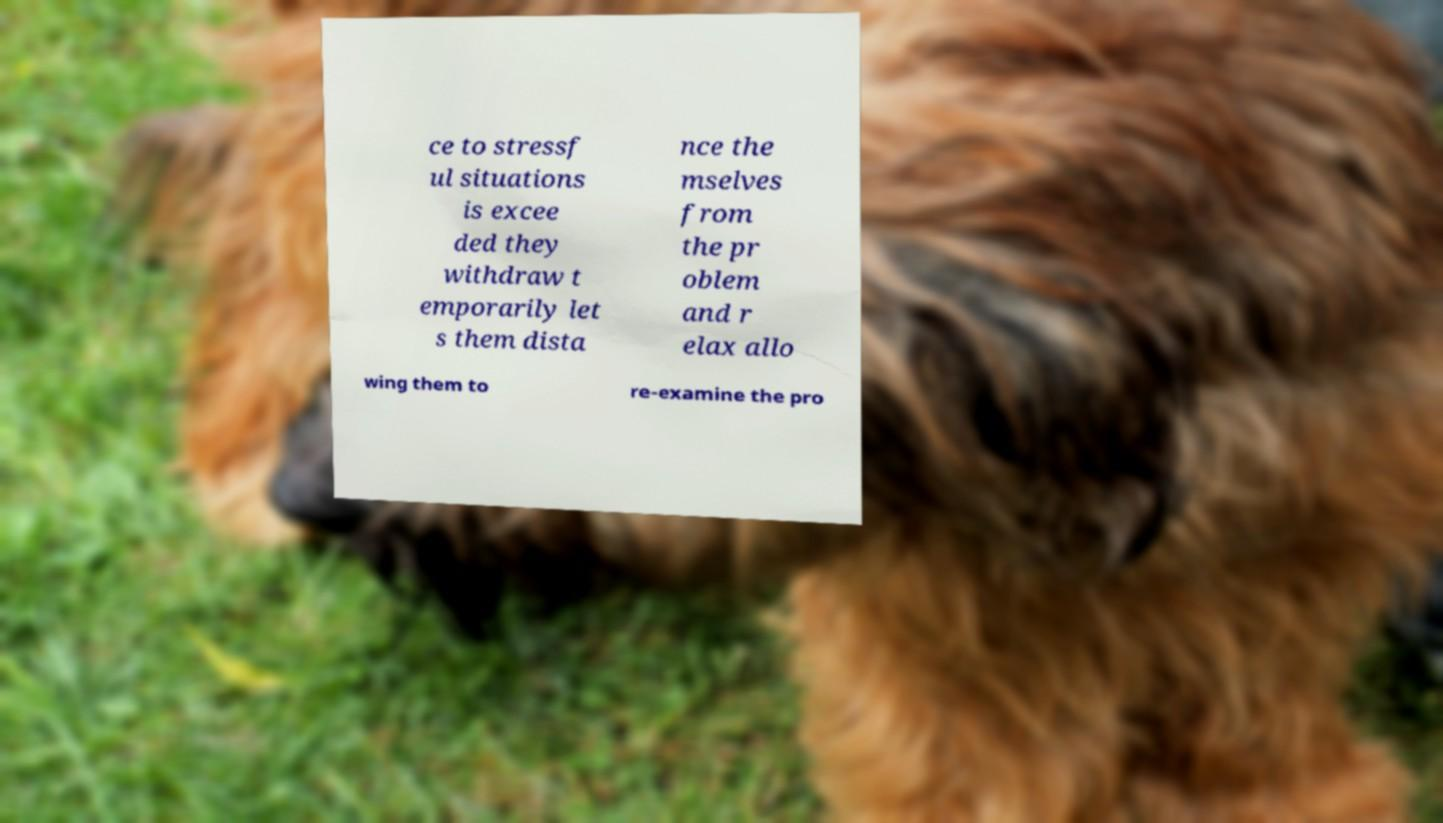Can you accurately transcribe the text from the provided image for me? ce to stressf ul situations is excee ded they withdraw t emporarily let s them dista nce the mselves from the pr oblem and r elax allo wing them to re-examine the pro 